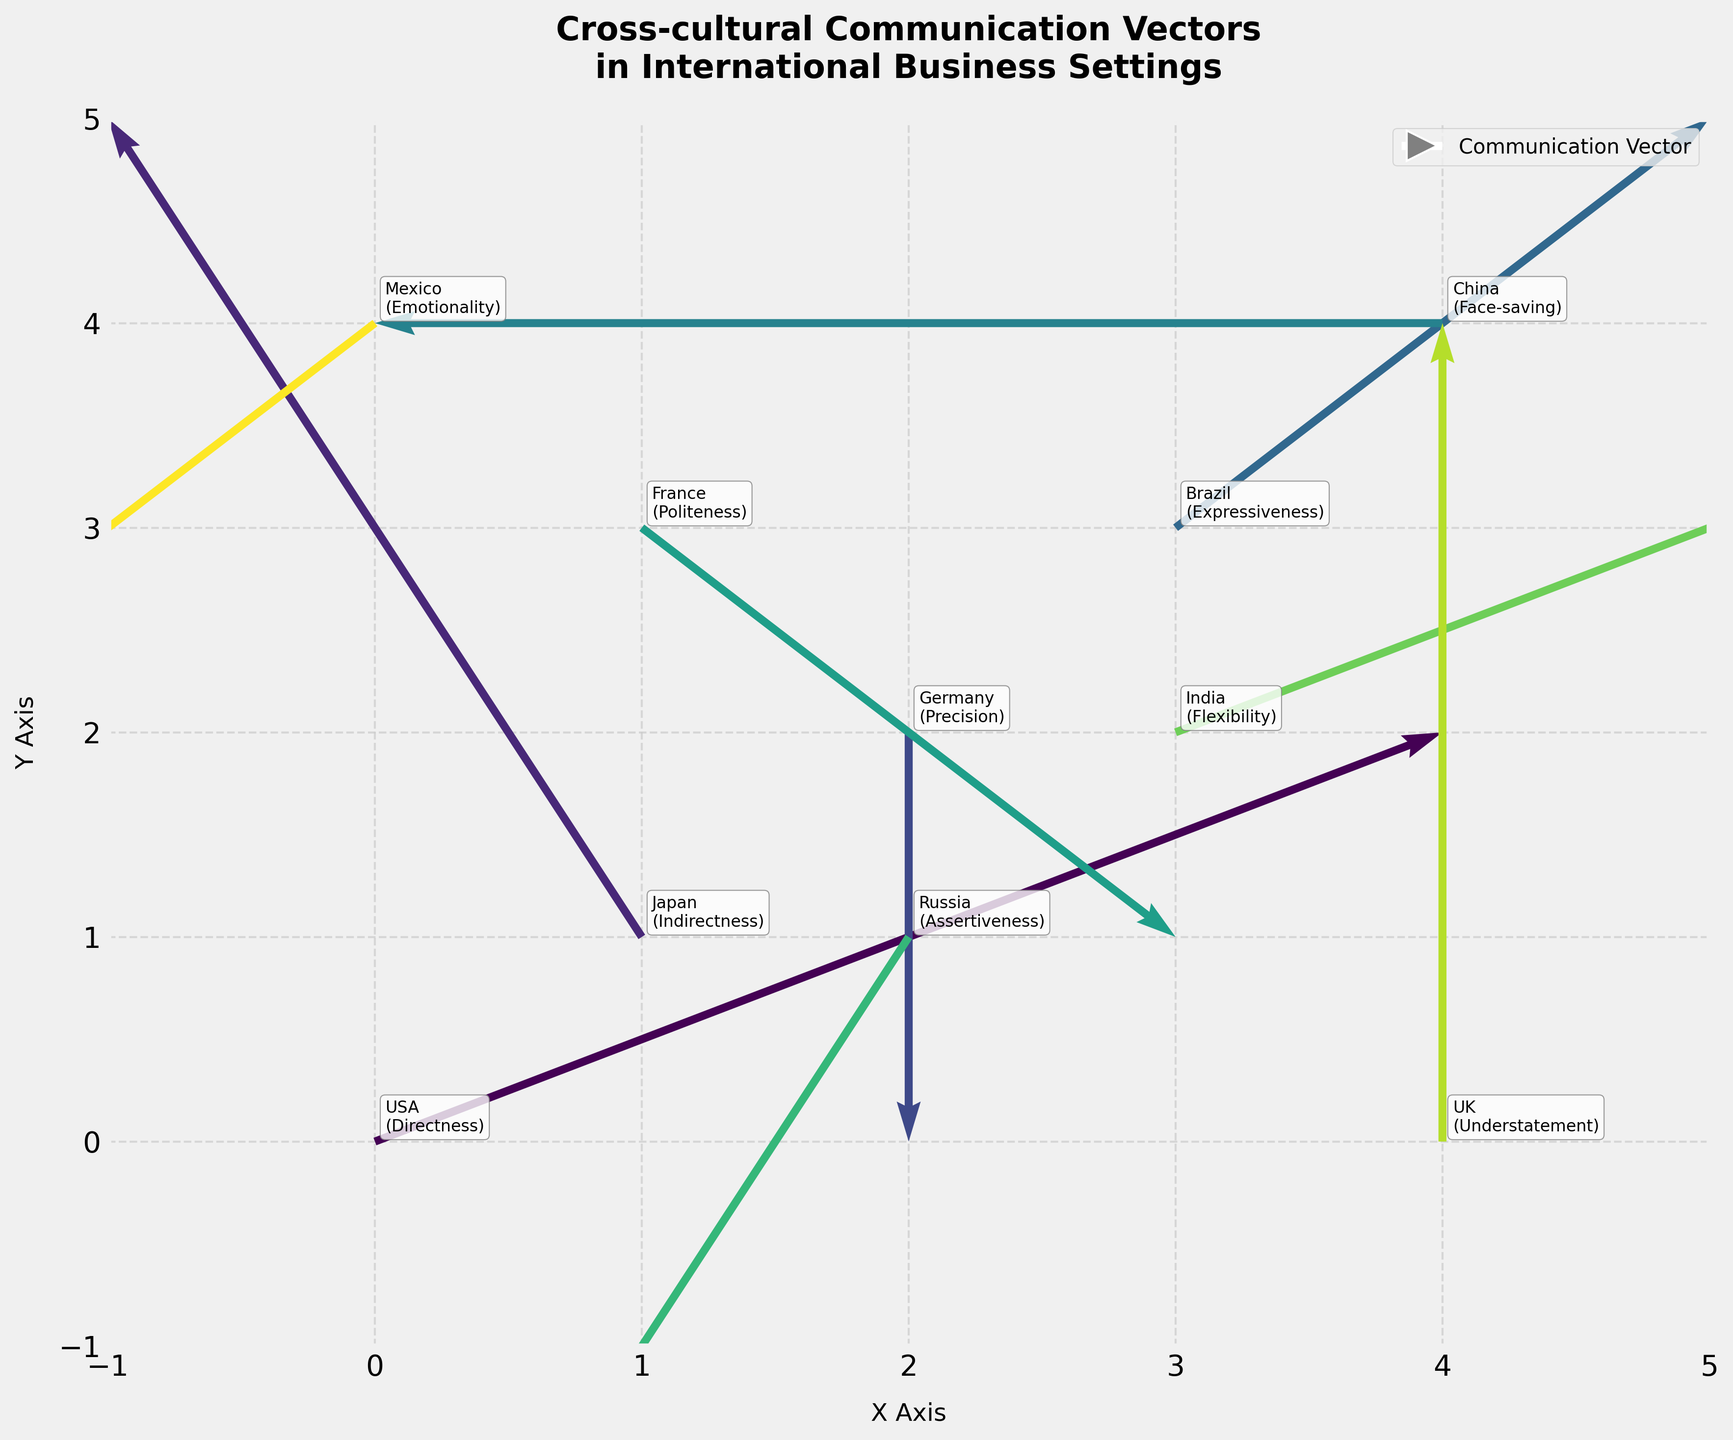What is the title of the figure? The title of the figure is written at the top of the plot in a large font. It states, "Cross-cultural Communication Vectors in International Business Settings."
Answer: Cross-cultural Communication Vectors in International Business Settings What are the x-axis and y-axis labels? The x-axis and y-axis labels are written along the horizontal and vertical axes of the plot. They are labeled as "X Axis" and "Y Axis," respectively.
Answer: X Axis; Y Axis Which culture shows the largest horizontal movement along the x-axis? Observing the vectors, the culture with the largest horizontal movement along the x-axis would be the one with the highest absolute value in the U component. India has U=2, which is the largest positive horizontal movement.
Answer: India What is the direction and magnitude of the vector associated with Japan? The vector for Japan has components U=-1 and V=2. The direction is from (1,1) to (0,3), and the magnitude can be calculated using the Pythagorean theorem: sqrt((-1)^2 + 2^2) = sqrt(5).
Answer: Direction: from (1,1) to (0,3); Magnitude: sqrt(5) Which culture represents the pragmatic strategy of "Flexibility"? The culture and pragmatic strategy are annotated next to each vector. The culture corresponding to "Flexibility" is annotated next to the vector associated with India.
Answer: India How many cultures are represented in the figure? Each vector represents a different culture and its pragmatic strategy. By counting the number of vectors or the different culture annotations, there are 10 cultures represented.
Answer: 10 Compare the directional flow of pragmatic strategies between the USA and Russia. Which direction does each follow? For the USA, the vector components are (2,1), indicating a movement to the right and upwards. For Russia, the vector components are (-1,-2), indicating a movement to the left and downwards.
Answer: USA: right and upwards; Russia: left and downwards What is the net vertical displacement for the pragmatic strategies of France and UK combined? For France, V=-1 and for the UK, V=2. The net vertical displacement is the sum of these: -1 + 2 = 1.
Answer: 1 What is the general observational trend of the cultural vectors from the quiver plot? Observing the entire plot, each vector shows a different pragmatic strategy represented as arrows pointing in various directions, indicating both the diversity of communication styles and the multidirectional flow in international business settings.
Answer: Multidirectional flow and diversity 